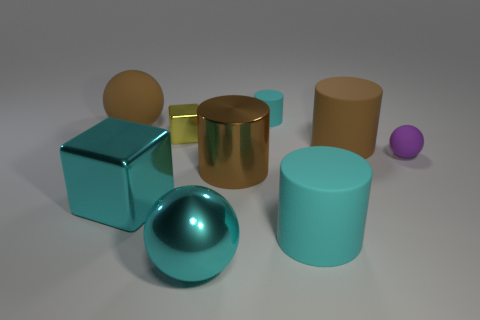What is the shape of the large metal thing that is the same color as the large metal block?
Offer a terse response. Sphere. Are there an equal number of large balls that are behind the tiny purple object and large yellow rubber things?
Your answer should be compact. No. How many other objects are there of the same shape as the small yellow object?
Your answer should be very brief. 1. What is the shape of the purple rubber thing?
Make the answer very short. Sphere. Is the material of the small purple object the same as the tiny yellow thing?
Keep it short and to the point. No. Is the number of brown cylinders that are on the right side of the large brown matte cylinder the same as the number of brown things to the right of the small purple matte thing?
Your response must be concise. Yes. There is a large rubber thing that is in front of the small matte object in front of the tiny yellow shiny thing; are there any small purple matte objects that are in front of it?
Keep it short and to the point. No. Is the size of the cyan sphere the same as the brown ball?
Offer a very short reply. Yes. There is a rubber thing on the left side of the large cyan metallic thing in front of the cyan rubber object that is in front of the small cyan thing; what is its color?
Ensure brevity in your answer.  Brown. What number of things are the same color as the big matte ball?
Make the answer very short. 2. 